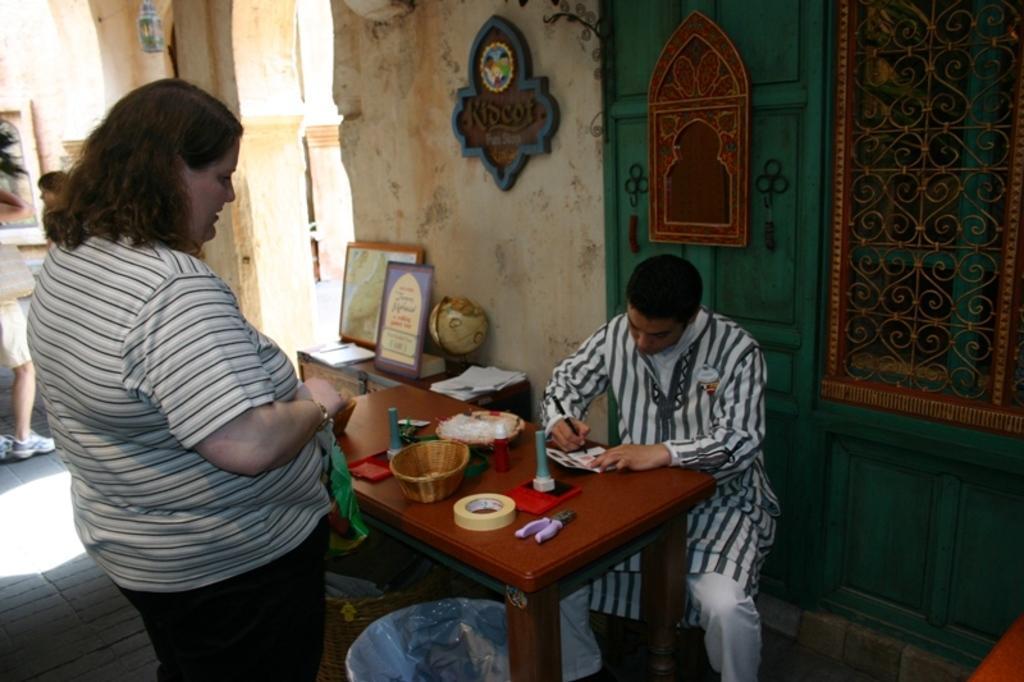Describe this image in one or two sentences. Here we can see a man sitting on a chair with table in front of him and in front of him there is a woman standing, the man is writing something on a paper with a pen and there are lots of things on the table 